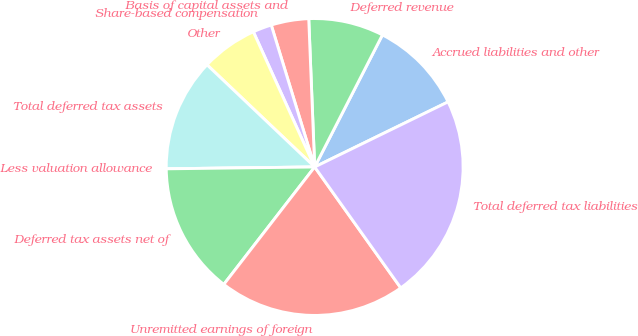<chart> <loc_0><loc_0><loc_500><loc_500><pie_chart><fcel>Accrued liabilities and other<fcel>Deferred revenue<fcel>Basis of capital assets and<fcel>Share-based compensation<fcel>Other<fcel>Total deferred tax assets<fcel>Less valuation allowance<fcel>Deferred tax assets net of<fcel>Unremitted earnings of foreign<fcel>Total deferred tax liabilities<nl><fcel>10.23%<fcel>8.18%<fcel>4.09%<fcel>2.05%<fcel>6.14%<fcel>12.28%<fcel>0.0%<fcel>14.32%<fcel>20.33%<fcel>22.38%<nl></chart> 